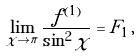Convert formula to latex. <formula><loc_0><loc_0><loc_500><loc_500>\lim _ { \chi \to \pi } \frac { f ^ { ( 1 ) } } { \sin ^ { 2 } \chi } = F _ { 1 } \, ,</formula> 